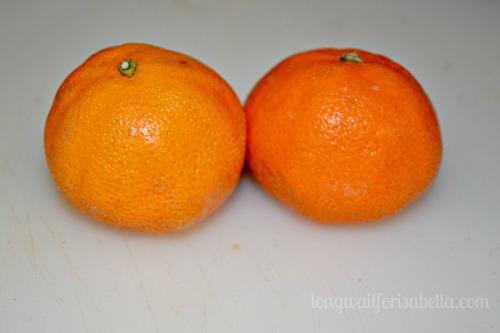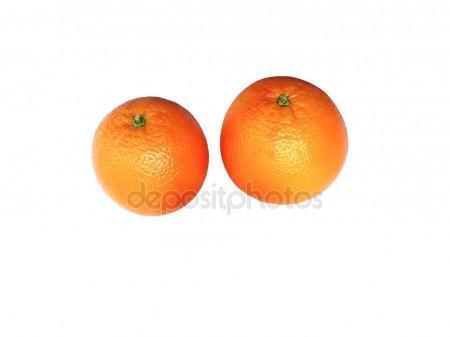The first image is the image on the left, the second image is the image on the right. Given the left and right images, does the statement "There are four uncut oranges." hold true? Answer yes or no. Yes. The first image is the image on the left, the second image is the image on the right. Evaluate the accuracy of this statement regarding the images: "In total, the images contain the equivalent of four oranges.". Is it true? Answer yes or no. Yes. 